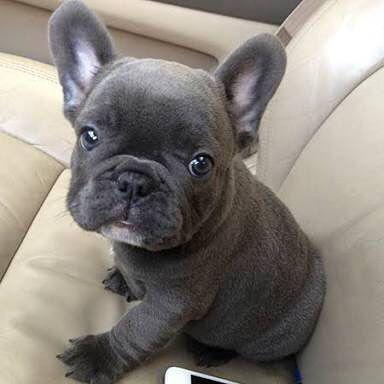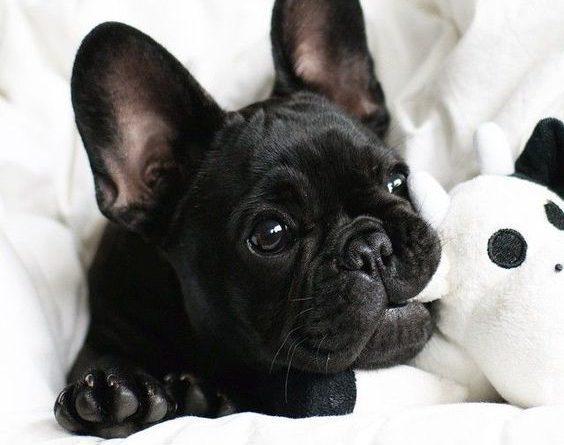The first image is the image on the left, the second image is the image on the right. For the images displayed, is the sentence "One of the images shows exactly two dogs." factually correct? Answer yes or no. No. 